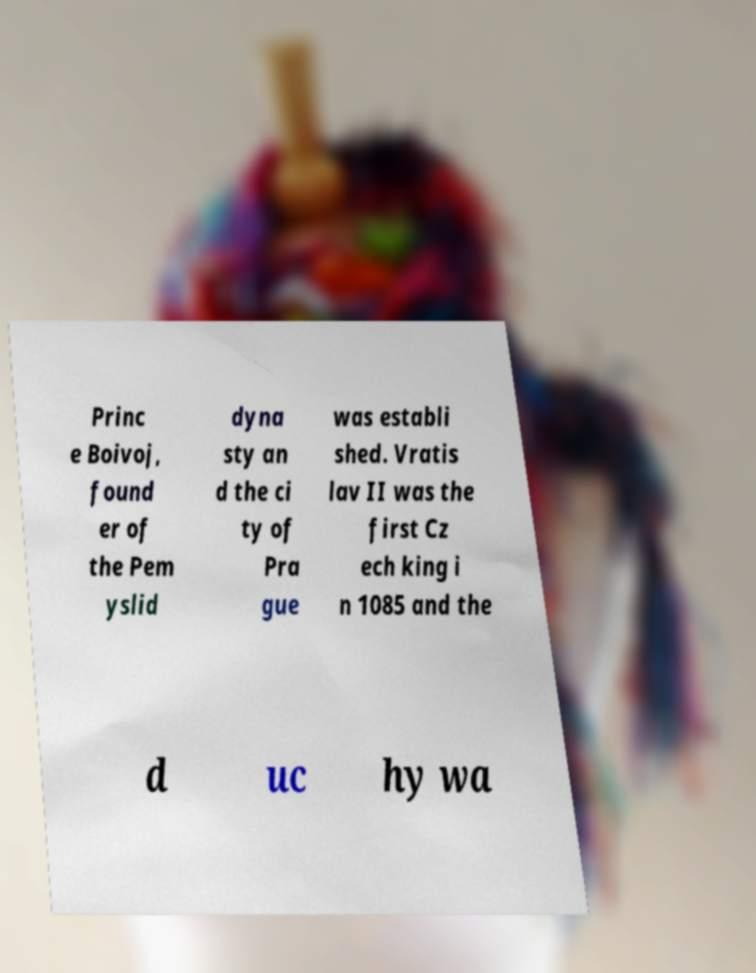For documentation purposes, I need the text within this image transcribed. Could you provide that? Princ e Boivoj, found er of the Pem yslid dyna sty an d the ci ty of Pra gue was establi shed. Vratis lav II was the first Cz ech king i n 1085 and the d uc hy wa 